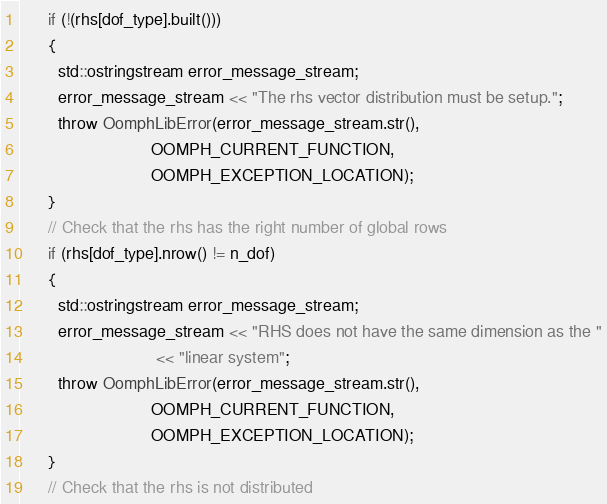Convert code to text. <code><loc_0><loc_0><loc_500><loc_500><_C_>      if (!(rhs[dof_type].built()))
      {
        std::ostringstream error_message_stream;
        error_message_stream << "The rhs vector distribution must be setup.";
        throw OomphLibError(error_message_stream.str(),
                            OOMPH_CURRENT_FUNCTION,
                            OOMPH_EXCEPTION_LOCATION);
      }
      // Check that the rhs has the right number of global rows
      if (rhs[dof_type].nrow() != n_dof)
      {
        std::ostringstream error_message_stream;
        error_message_stream << "RHS does not have the same dimension as the "
                             << "linear system";
        throw OomphLibError(error_message_stream.str(),
                            OOMPH_CURRENT_FUNCTION,
                            OOMPH_EXCEPTION_LOCATION);
      }
      // Check that the rhs is not distributed</code> 